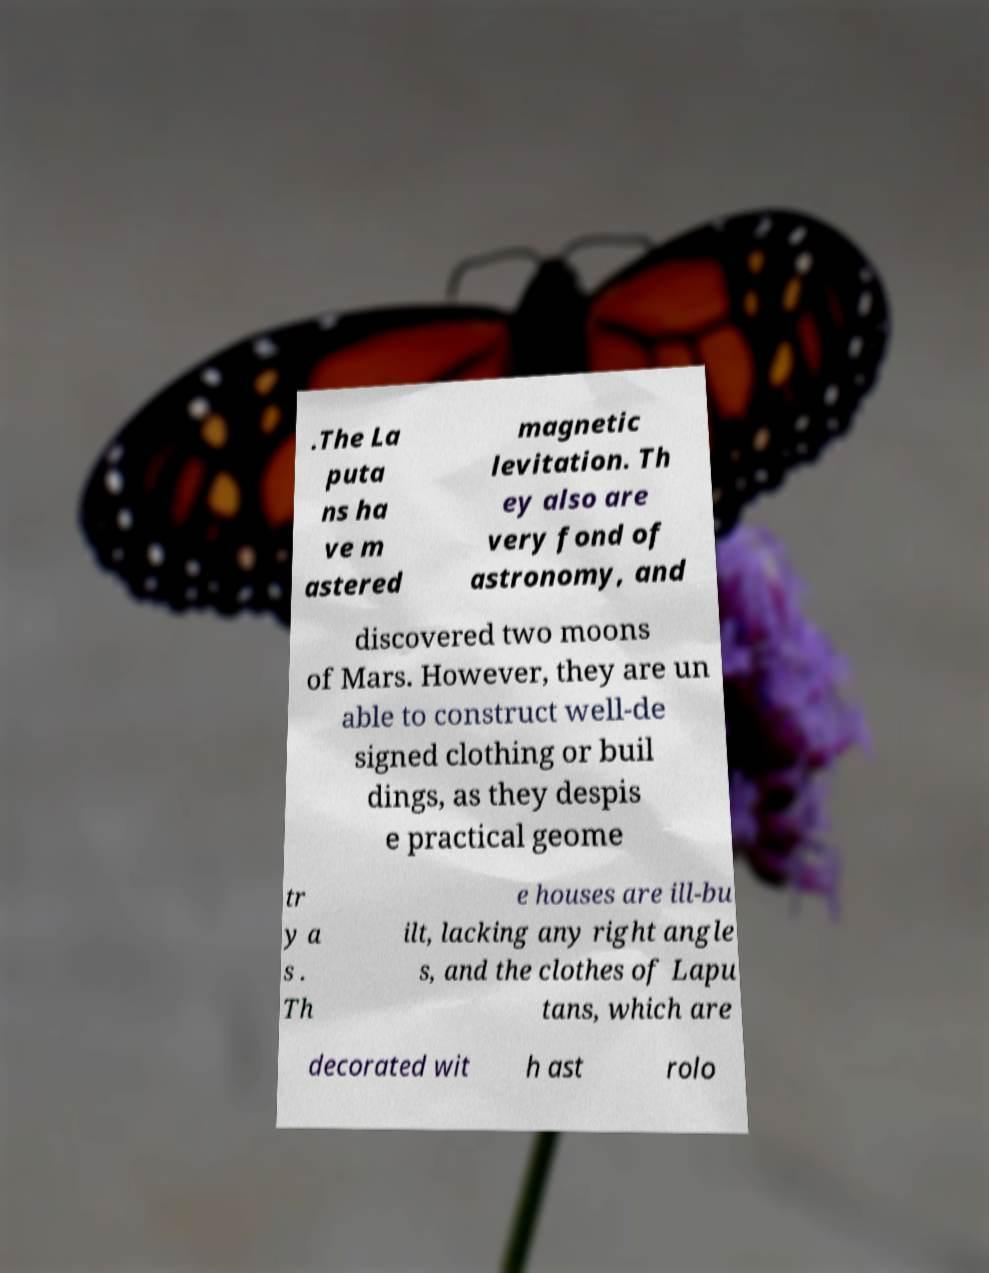Could you assist in decoding the text presented in this image and type it out clearly? .The La puta ns ha ve m astered magnetic levitation. Th ey also are very fond of astronomy, and discovered two moons of Mars. However, they are un able to construct well-de signed clothing or buil dings, as they despis e practical geome tr y a s . Th e houses are ill-bu ilt, lacking any right angle s, and the clothes of Lapu tans, which are decorated wit h ast rolo 